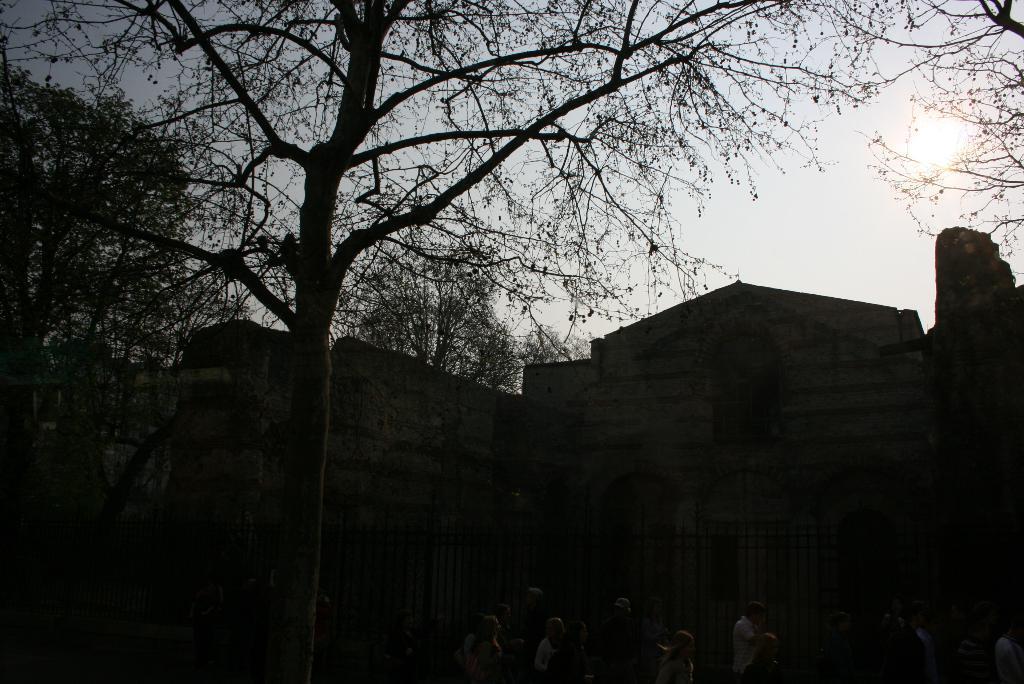In one or two sentences, can you explain what this image depicts? There are trees, a wall and other objects on a ground. In the background, there is a sun in the sky. 